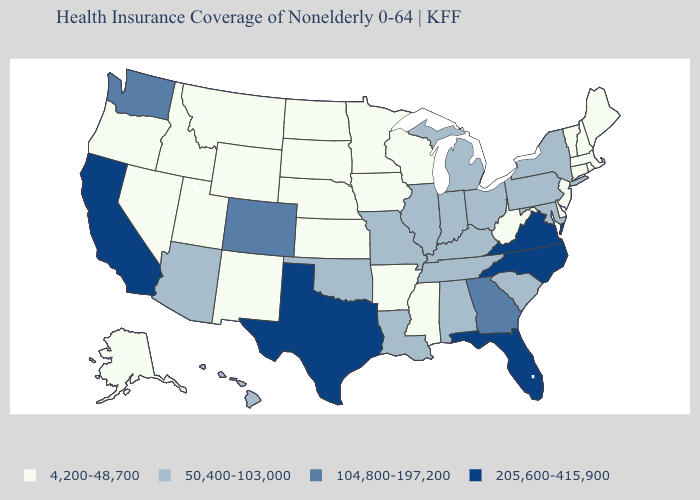Does Arkansas have the same value as South Carolina?
Short answer required. No. Name the states that have a value in the range 205,600-415,900?
Keep it brief. California, Florida, North Carolina, Texas, Virginia. Which states hav the highest value in the West?
Quick response, please. California. Name the states that have a value in the range 50,400-103,000?
Keep it brief. Alabama, Arizona, Hawaii, Illinois, Indiana, Kentucky, Louisiana, Maryland, Michigan, Missouri, New York, Ohio, Oklahoma, Pennsylvania, South Carolina, Tennessee. What is the highest value in the West ?
Answer briefly. 205,600-415,900. Name the states that have a value in the range 205,600-415,900?
Answer briefly. California, Florida, North Carolina, Texas, Virginia. Does the map have missing data?
Answer briefly. No. Is the legend a continuous bar?
Quick response, please. No. Among the states that border Wisconsin , does Michigan have the lowest value?
Write a very short answer. No. What is the highest value in states that border Vermont?
Write a very short answer. 50,400-103,000. Which states hav the highest value in the South?
Short answer required. Florida, North Carolina, Texas, Virginia. Does Louisiana have the same value as Arizona?
Give a very brief answer. Yes. Does Wisconsin have the highest value in the MidWest?
Be succinct. No. Does New York have the highest value in the Northeast?
Give a very brief answer. Yes. Does Wisconsin have a lower value than Rhode Island?
Keep it brief. No. 